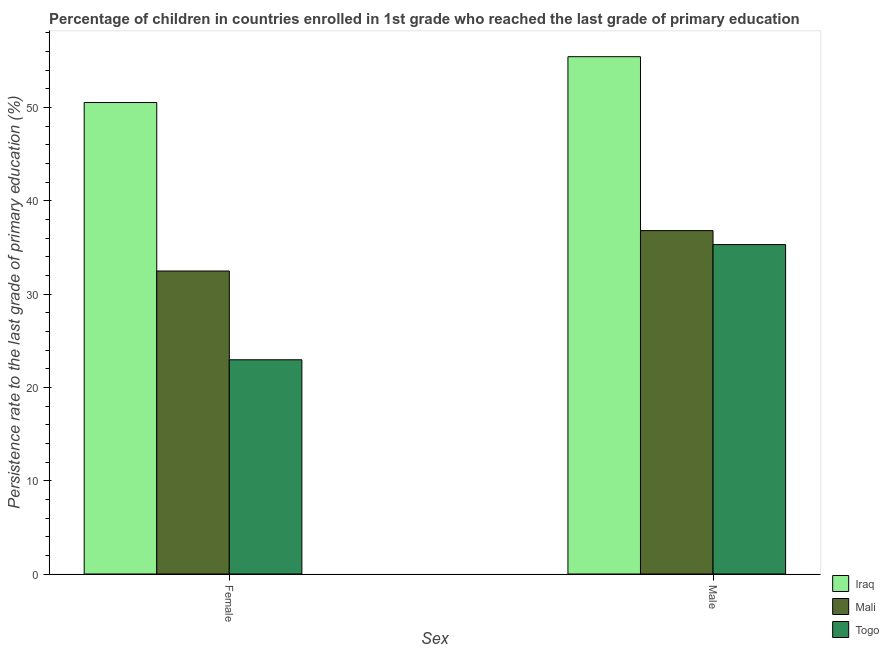How many groups of bars are there?
Provide a short and direct response. 2. Are the number of bars on each tick of the X-axis equal?
Provide a succinct answer. Yes. How many bars are there on the 1st tick from the left?
Offer a very short reply. 3. How many bars are there on the 2nd tick from the right?
Keep it short and to the point. 3. What is the persistence rate of male students in Mali?
Your answer should be very brief. 36.81. Across all countries, what is the maximum persistence rate of female students?
Make the answer very short. 50.54. Across all countries, what is the minimum persistence rate of female students?
Offer a very short reply. 22.96. In which country was the persistence rate of male students maximum?
Provide a short and direct response. Iraq. In which country was the persistence rate of female students minimum?
Offer a terse response. Togo. What is the total persistence rate of male students in the graph?
Provide a succinct answer. 127.58. What is the difference between the persistence rate of female students in Mali and that in Iraq?
Ensure brevity in your answer.  -18.06. What is the difference between the persistence rate of male students in Iraq and the persistence rate of female students in Mali?
Give a very brief answer. 22.97. What is the average persistence rate of male students per country?
Your answer should be very brief. 42.53. What is the difference between the persistence rate of male students and persistence rate of female students in Togo?
Your answer should be compact. 12.35. In how many countries, is the persistence rate of female students greater than 36 %?
Offer a terse response. 1. What is the ratio of the persistence rate of male students in Togo to that in Iraq?
Ensure brevity in your answer.  0.64. What does the 1st bar from the left in Male represents?
Keep it short and to the point. Iraq. What does the 1st bar from the right in Female represents?
Offer a terse response. Togo. How many bars are there?
Your response must be concise. 6. What is the difference between two consecutive major ticks on the Y-axis?
Your answer should be very brief. 10. Does the graph contain any zero values?
Offer a very short reply. No. Where does the legend appear in the graph?
Make the answer very short. Bottom right. How many legend labels are there?
Your answer should be very brief. 3. How are the legend labels stacked?
Provide a succinct answer. Vertical. What is the title of the graph?
Your answer should be very brief. Percentage of children in countries enrolled in 1st grade who reached the last grade of primary education. What is the label or title of the X-axis?
Keep it short and to the point. Sex. What is the label or title of the Y-axis?
Your answer should be very brief. Persistence rate to the last grade of primary education (%). What is the Persistence rate to the last grade of primary education (%) in Iraq in Female?
Your answer should be compact. 50.54. What is the Persistence rate to the last grade of primary education (%) of Mali in Female?
Make the answer very short. 32.48. What is the Persistence rate to the last grade of primary education (%) of Togo in Female?
Give a very brief answer. 22.96. What is the Persistence rate to the last grade of primary education (%) of Iraq in Male?
Provide a short and direct response. 55.46. What is the Persistence rate to the last grade of primary education (%) of Mali in Male?
Offer a terse response. 36.81. What is the Persistence rate to the last grade of primary education (%) of Togo in Male?
Provide a short and direct response. 35.31. Across all Sex, what is the maximum Persistence rate to the last grade of primary education (%) in Iraq?
Your response must be concise. 55.46. Across all Sex, what is the maximum Persistence rate to the last grade of primary education (%) in Mali?
Provide a short and direct response. 36.81. Across all Sex, what is the maximum Persistence rate to the last grade of primary education (%) in Togo?
Make the answer very short. 35.31. Across all Sex, what is the minimum Persistence rate to the last grade of primary education (%) in Iraq?
Provide a short and direct response. 50.54. Across all Sex, what is the minimum Persistence rate to the last grade of primary education (%) of Mali?
Provide a short and direct response. 32.48. Across all Sex, what is the minimum Persistence rate to the last grade of primary education (%) of Togo?
Your response must be concise. 22.96. What is the total Persistence rate to the last grade of primary education (%) of Iraq in the graph?
Make the answer very short. 106. What is the total Persistence rate to the last grade of primary education (%) of Mali in the graph?
Offer a terse response. 69.29. What is the total Persistence rate to the last grade of primary education (%) in Togo in the graph?
Offer a very short reply. 58.28. What is the difference between the Persistence rate to the last grade of primary education (%) in Iraq in Female and that in Male?
Your answer should be compact. -4.91. What is the difference between the Persistence rate to the last grade of primary education (%) in Mali in Female and that in Male?
Offer a very short reply. -4.33. What is the difference between the Persistence rate to the last grade of primary education (%) of Togo in Female and that in Male?
Your answer should be compact. -12.35. What is the difference between the Persistence rate to the last grade of primary education (%) of Iraq in Female and the Persistence rate to the last grade of primary education (%) of Mali in Male?
Your answer should be compact. 13.73. What is the difference between the Persistence rate to the last grade of primary education (%) of Iraq in Female and the Persistence rate to the last grade of primary education (%) of Togo in Male?
Your answer should be compact. 15.23. What is the difference between the Persistence rate to the last grade of primary education (%) of Mali in Female and the Persistence rate to the last grade of primary education (%) of Togo in Male?
Your answer should be compact. -2.83. What is the average Persistence rate to the last grade of primary education (%) in Iraq per Sex?
Provide a short and direct response. 53. What is the average Persistence rate to the last grade of primary education (%) of Mali per Sex?
Your response must be concise. 34.65. What is the average Persistence rate to the last grade of primary education (%) of Togo per Sex?
Your response must be concise. 29.14. What is the difference between the Persistence rate to the last grade of primary education (%) in Iraq and Persistence rate to the last grade of primary education (%) in Mali in Female?
Give a very brief answer. 18.06. What is the difference between the Persistence rate to the last grade of primary education (%) of Iraq and Persistence rate to the last grade of primary education (%) of Togo in Female?
Ensure brevity in your answer.  27.58. What is the difference between the Persistence rate to the last grade of primary education (%) in Mali and Persistence rate to the last grade of primary education (%) in Togo in Female?
Give a very brief answer. 9.52. What is the difference between the Persistence rate to the last grade of primary education (%) of Iraq and Persistence rate to the last grade of primary education (%) of Mali in Male?
Make the answer very short. 18.65. What is the difference between the Persistence rate to the last grade of primary education (%) of Iraq and Persistence rate to the last grade of primary education (%) of Togo in Male?
Offer a terse response. 20.14. What is the difference between the Persistence rate to the last grade of primary education (%) in Mali and Persistence rate to the last grade of primary education (%) in Togo in Male?
Your answer should be compact. 1.5. What is the ratio of the Persistence rate to the last grade of primary education (%) in Iraq in Female to that in Male?
Give a very brief answer. 0.91. What is the ratio of the Persistence rate to the last grade of primary education (%) of Mali in Female to that in Male?
Ensure brevity in your answer.  0.88. What is the ratio of the Persistence rate to the last grade of primary education (%) in Togo in Female to that in Male?
Ensure brevity in your answer.  0.65. What is the difference between the highest and the second highest Persistence rate to the last grade of primary education (%) in Iraq?
Offer a terse response. 4.91. What is the difference between the highest and the second highest Persistence rate to the last grade of primary education (%) of Mali?
Make the answer very short. 4.33. What is the difference between the highest and the second highest Persistence rate to the last grade of primary education (%) in Togo?
Offer a terse response. 12.35. What is the difference between the highest and the lowest Persistence rate to the last grade of primary education (%) in Iraq?
Ensure brevity in your answer.  4.91. What is the difference between the highest and the lowest Persistence rate to the last grade of primary education (%) of Mali?
Provide a short and direct response. 4.33. What is the difference between the highest and the lowest Persistence rate to the last grade of primary education (%) in Togo?
Your answer should be very brief. 12.35. 